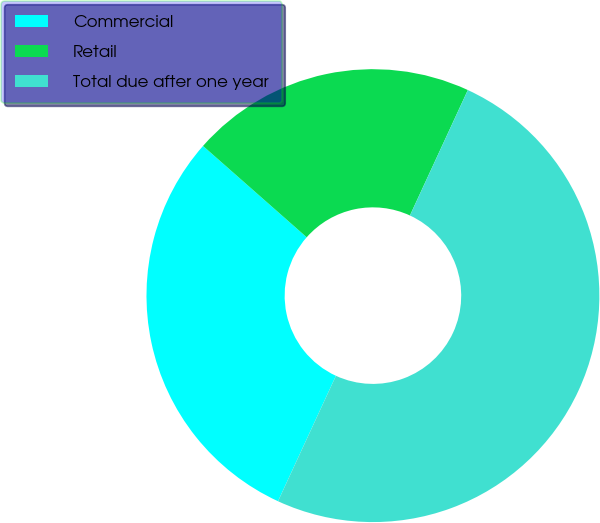Convert chart to OTSL. <chart><loc_0><loc_0><loc_500><loc_500><pie_chart><fcel>Commercial<fcel>Retail<fcel>Total due after one year<nl><fcel>29.61%<fcel>20.39%<fcel>50.0%<nl></chart> 